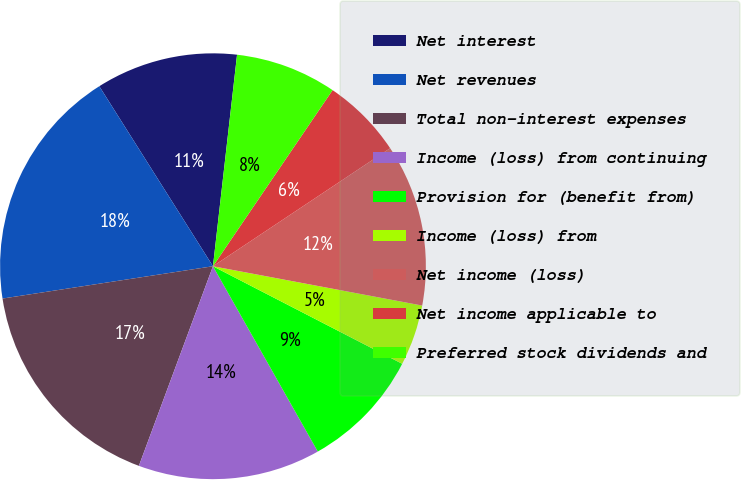Convert chart. <chart><loc_0><loc_0><loc_500><loc_500><pie_chart><fcel>Net interest<fcel>Net revenues<fcel>Total non-interest expenses<fcel>Income (loss) from continuing<fcel>Provision for (benefit from)<fcel>Income (loss) from<fcel>Net income (loss)<fcel>Net income applicable to<fcel>Preferred stock dividends and<nl><fcel>10.77%<fcel>18.46%<fcel>16.92%<fcel>13.85%<fcel>9.23%<fcel>4.62%<fcel>12.31%<fcel>6.15%<fcel>7.69%<nl></chart> 